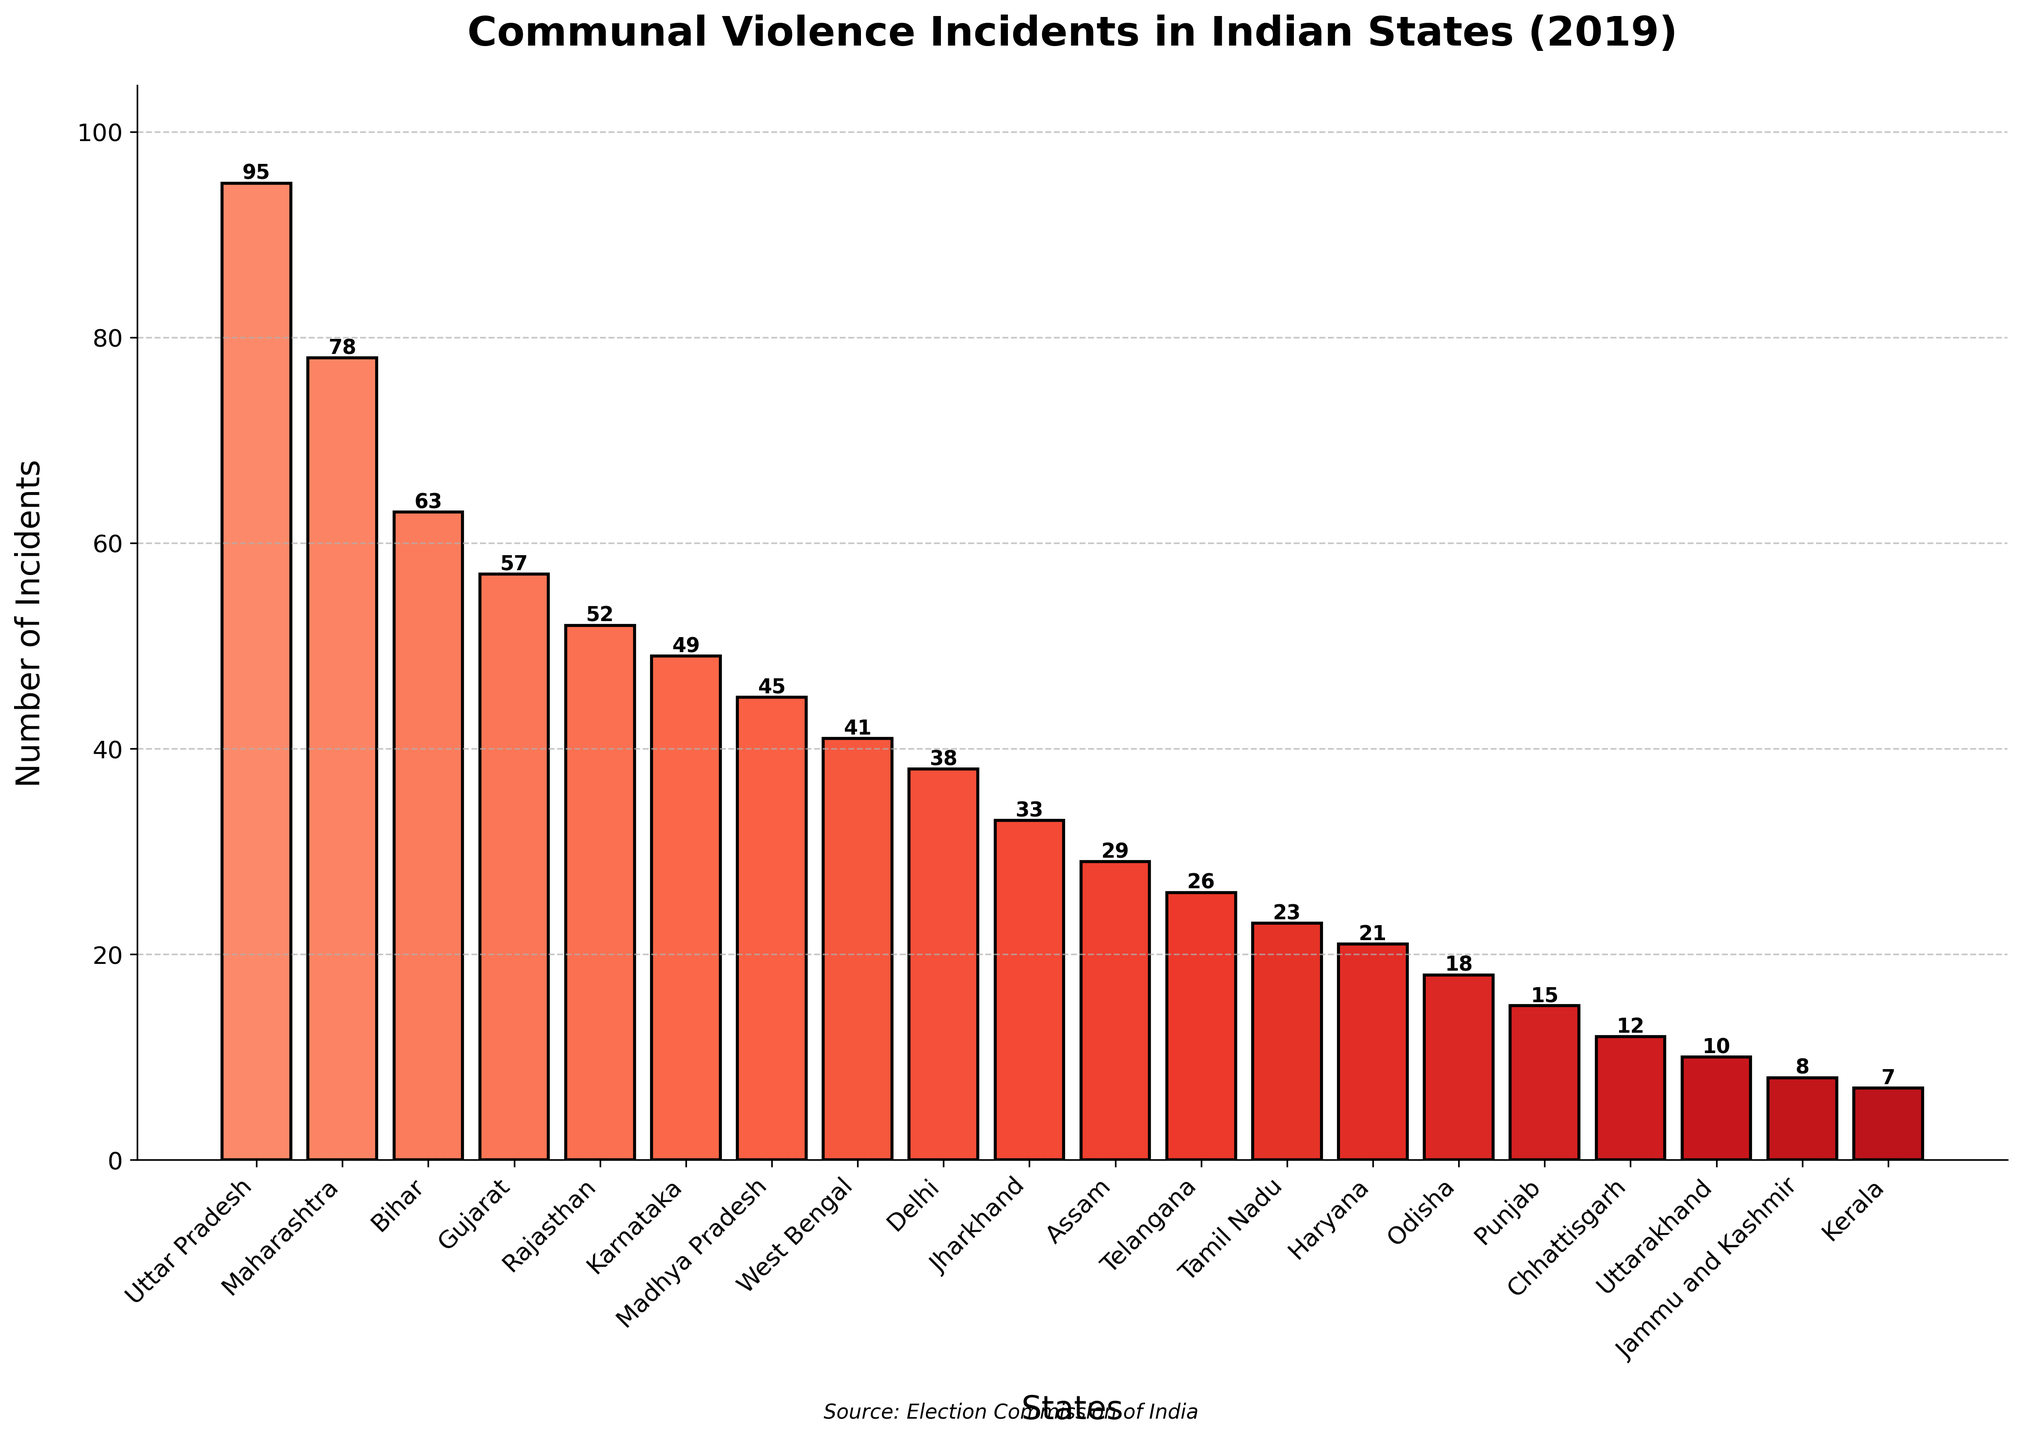Which state reported the highest number of communal violence incidents in 2019? The state with the tallest bar represents the highest number of incidents. Uttar Pradesh's bar is the tallest.
Answer: Uttar Pradesh Which state reported the lowest number of communal violence incidents in 2019? The state with the shortest bar represents the lowest number of incidents. Kerala's bar is the shortest.
Answer: Kerala Which states reported more incidents of communal violence in 2019, Maharashtra or Bihar? Compare the heights of the bars representing Maharashtra and Bihar. Maharashtra (78) has a taller bar than Bihar (63).
Answer: Maharashtra What is the total number of communal violence incidents reported in Gujarat and Rajasthan combined? Add the number of incidents reported in Gujarat (57) and Rajasthan (52). The sum is 57 + 52 = 109.
Answer: 109 How many more incidents were reported in Uttar Pradesh than in Delhi in 2019? Subtract the number of incidents in Delhi (38) from those in Uttar Pradesh (95). The difference is 95 - 38 = 57.
Answer: 57 What's the average number of communal violence incidents reported in Karnataka, Jharkhand, and Assam in 2019? Add the numbers for Karnataka (49), Jharkhand (33), and Assam (29), then divide by 3. The sum is 49 + 33 + 29 = 111; the average is 111 / 3 = 37.
Answer: 37 Which state reported fewer incidents, Odisha or Telangana? Compare the heights of the bars representing Odisha and Telangana. Odisha (18) has a shorter bar than Telangana (26).
Answer: Odisha Which states had incidents between 20 and 30 in 2019? Identify the bars where the number of incidents falls within the range of 20 to 30. Assam (29), Telangana (26), and Tamil Nadu (23) fall within this range.
Answer: Assam, Telangana, Tamil Nadu How many states reported fewer than 15 incidents in 2019? Count the bars representing less than 15 incidents. States are Punjab (15), Chhattisgarh (12), Uttarakhand (10), Jammu and Kashmir (8), and Kerala (7). There are 5 states in total.
Answer: 5 What's the difference in the number of incidents between the state with the second-highest and the state with the third-highest incidents? Find the differences between Maharashtra (78, second-highest) and Bihar (63, third-highest). The difference is 78 - 63 = 15.
Answer: 15 